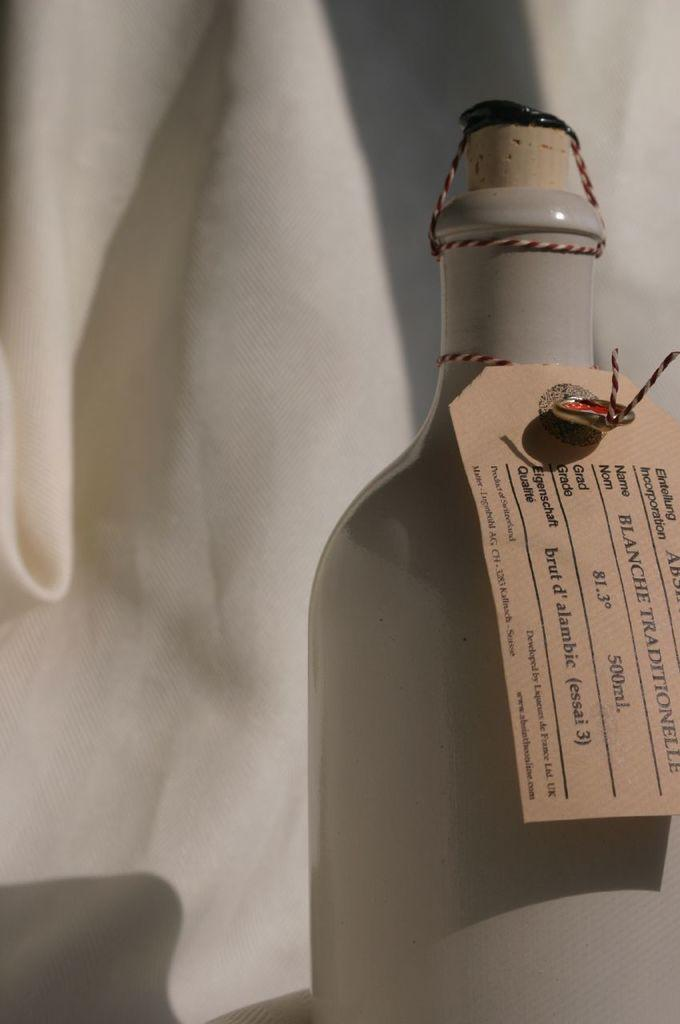What object can be seen in the image in the image? There is a bottle in the image. Is there any additional information provided on the bottle? Yes, there is a tag in the image. What color is the background of the image? The background of the image is white. How many bikes are parked in the background of the image? There are no bikes present in the image; the background is white. What type of afterthought is mentioned on the tag in the image? There is no mention of an afterthought on the tag in the image. 